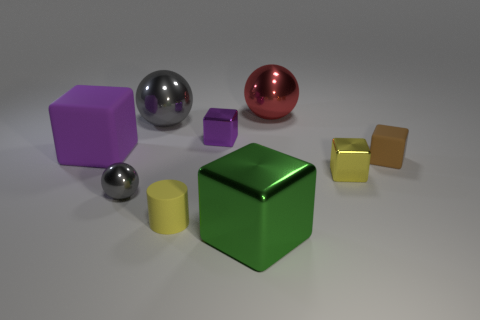How many other tiny brown balls have the same material as the tiny sphere?
Your response must be concise. 0. There is a tiny sphere that is made of the same material as the large green object; what is its color?
Make the answer very short. Gray. There is a purple rubber object; is it the same size as the gray metal ball that is in front of the purple shiny cube?
Your answer should be very brief. No. There is a yellow block to the left of the thing that is right of the small yellow object behind the tiny gray metal ball; what is its material?
Ensure brevity in your answer.  Metal. What number of things are small purple shiny blocks or red metallic balls?
Give a very brief answer. 2. Is the color of the big block on the left side of the yellow matte cylinder the same as the sphere that is in front of the tiny brown matte block?
Give a very brief answer. No. The purple thing that is the same size as the green object is what shape?
Your answer should be very brief. Cube. How many objects are either shiny cubes that are behind the tiny rubber cylinder or green objects on the right side of the yellow rubber object?
Your answer should be compact. 3. Are there fewer cubes than tiny green metallic objects?
Provide a short and direct response. No. There is a purple object that is the same size as the red metal sphere; what is it made of?
Provide a short and direct response. Rubber. 